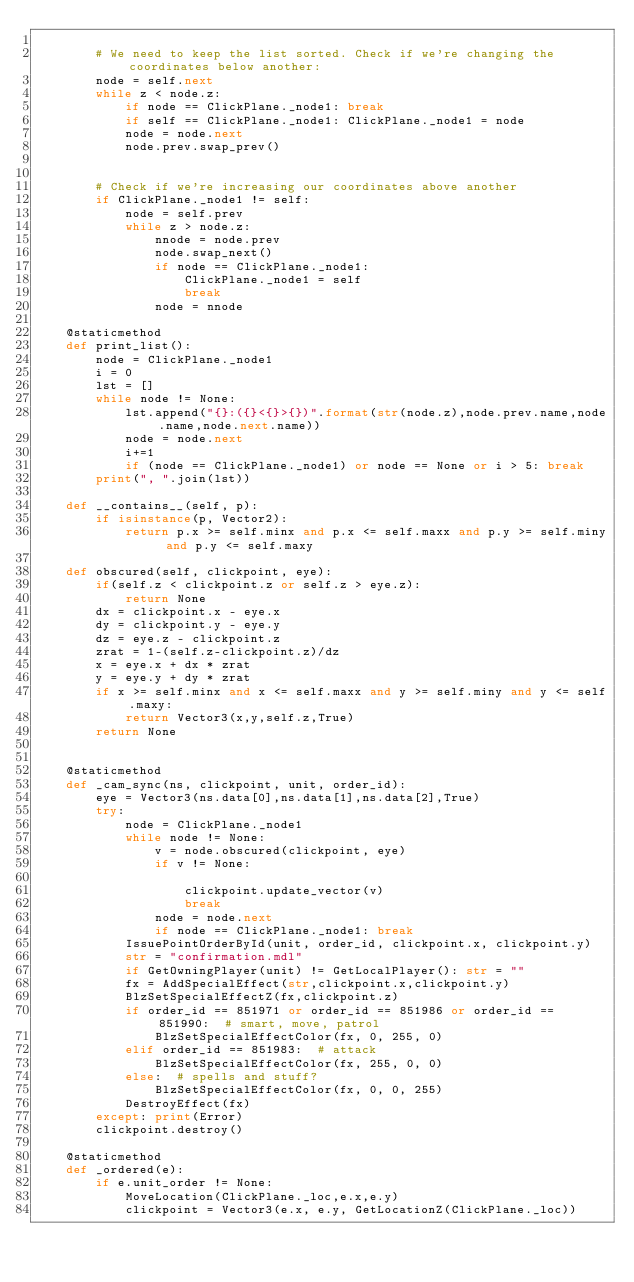<code> <loc_0><loc_0><loc_500><loc_500><_Python_>
        # We need to keep the list sorted. Check if we're changing the coordinates below another:
        node = self.next
        while z < node.z:
            if node == ClickPlane._node1: break
            if self == ClickPlane._node1: ClickPlane._node1 = node
            node = node.next
            node.prev.swap_prev()


        # Check if we're increasing our coordinates above another
        if ClickPlane._node1 != self:
            node = self.prev
            while z > node.z:
                nnode = node.prev
                node.swap_next()
                if node == ClickPlane._node1:
                    ClickPlane._node1 = self
                    break
                node = nnode

    @staticmethod
    def print_list():
        node = ClickPlane._node1
        i = 0
        lst = []
        while node != None:
            lst.append("{}:({}<{}>{})".format(str(node.z),node.prev.name,node.name,node.next.name))
            node = node.next
            i+=1
            if (node == ClickPlane._node1) or node == None or i > 5: break
        print(", ".join(lst))

    def __contains__(self, p):
        if isinstance(p, Vector2):
            return p.x >= self.minx and p.x <= self.maxx and p.y >= self.miny and p.y <= self.maxy

    def obscured(self, clickpoint, eye):
        if(self.z < clickpoint.z or self.z > eye.z):
            return None
        dx = clickpoint.x - eye.x
        dy = clickpoint.y - eye.y
        dz = eye.z - clickpoint.z
        zrat = 1-(self.z-clickpoint.z)/dz
        x = eye.x + dx * zrat
        y = eye.y + dy * zrat
        if x >= self.minx and x <= self.maxx and y >= self.miny and y <= self.maxy:
            return Vector3(x,y,self.z,True)
        return None


    @staticmethod
    def _cam_sync(ns, clickpoint, unit, order_id):
        eye = Vector3(ns.data[0],ns.data[1],ns.data[2],True)
        try:
            node = ClickPlane._node1
            while node != None:
                v = node.obscured(clickpoint, eye)
                if v != None:

                    clickpoint.update_vector(v)
                    break
                node = node.next
                if node == ClickPlane._node1: break
            IssuePointOrderById(unit, order_id, clickpoint.x, clickpoint.y)
            str = "confirmation.mdl"
            if GetOwningPlayer(unit) != GetLocalPlayer(): str = ""
            fx = AddSpecialEffect(str,clickpoint.x,clickpoint.y)
            BlzSetSpecialEffectZ(fx,clickpoint.z)
            if order_id == 851971 or order_id == 851986 or order_id == 851990:  # smart, move, patrol
                BlzSetSpecialEffectColor(fx, 0, 255, 0)
            elif order_id == 851983:  # attack
                BlzSetSpecialEffectColor(fx, 255, 0, 0)
            else:  # spells and stuff?
                BlzSetSpecialEffectColor(fx, 0, 0, 255)
            DestroyEffect(fx)
        except: print(Error)
        clickpoint.destroy()

    @staticmethod
    def _ordered(e):
        if e.unit_order != None:
            MoveLocation(ClickPlane._loc,e.x,e.y)
            clickpoint = Vector3(e.x, e.y, GetLocationZ(ClickPlane._loc))</code> 